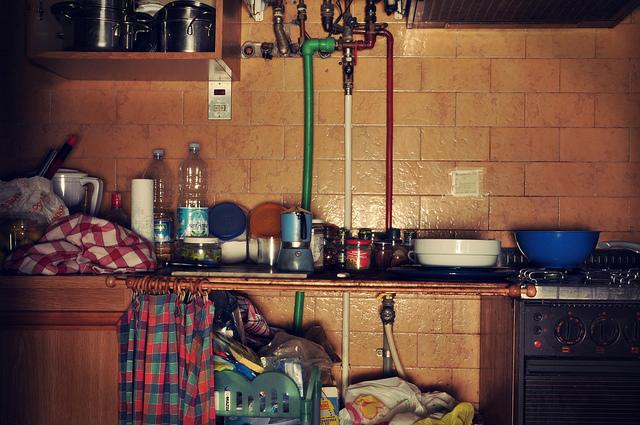When the pipes need to be worked on plumbers will be blocked from reaching it by what? Please explain your reasoning. counter. There is a counter right in front of the pipe. 